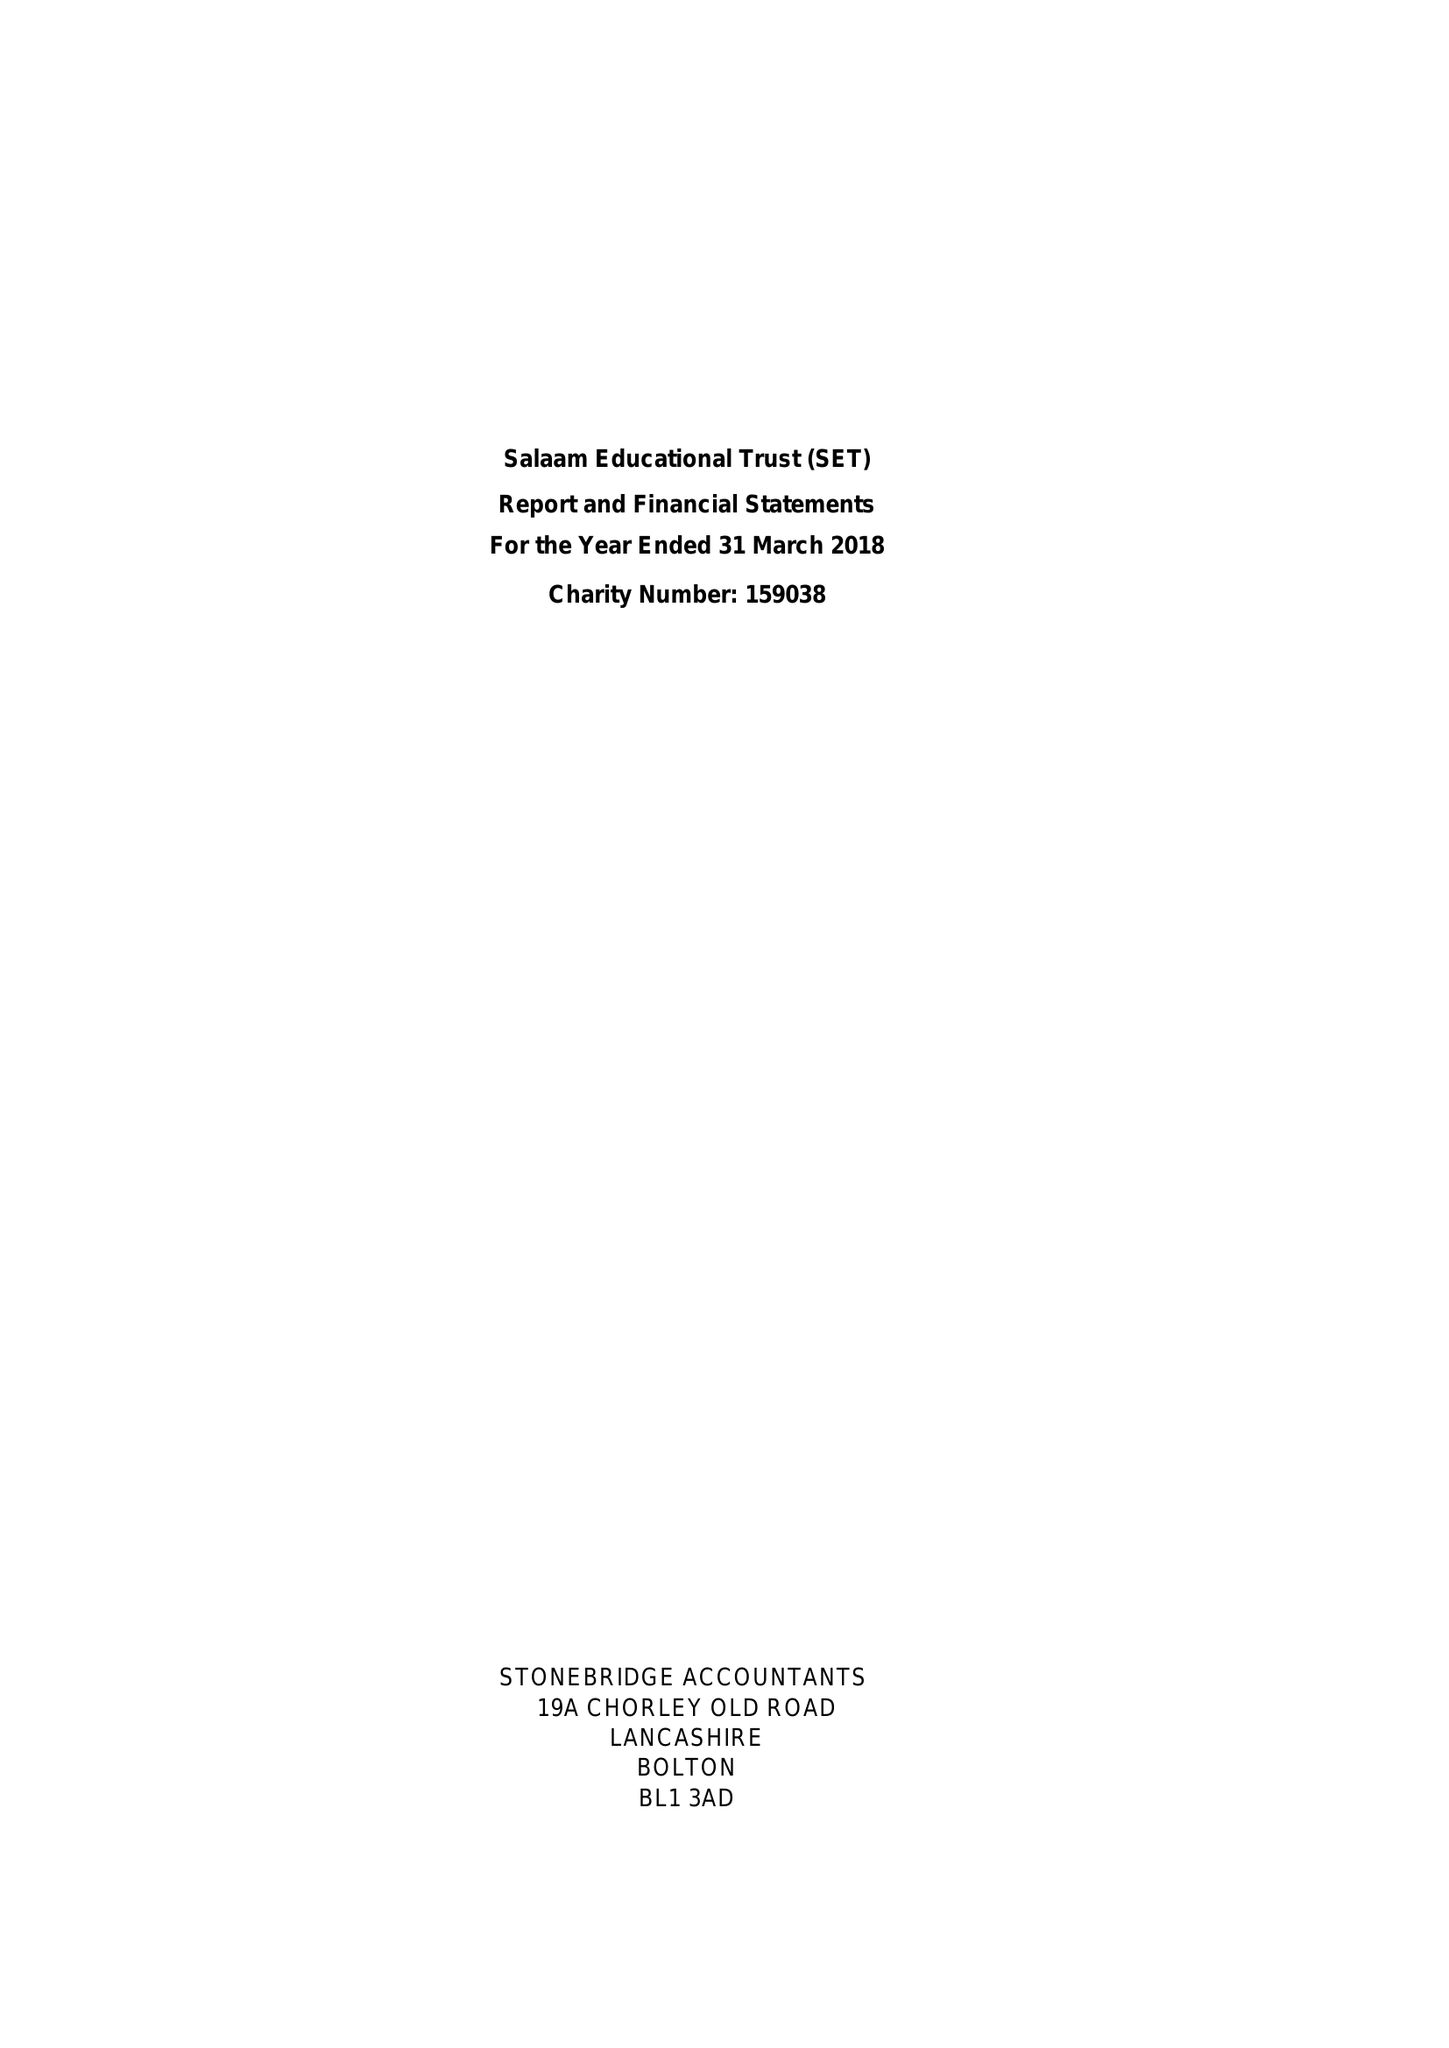What is the value for the charity_number?
Answer the question using a single word or phrase. 1159038 